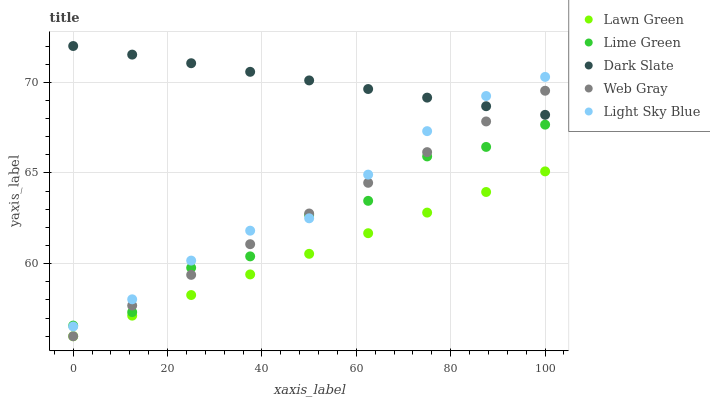Does Lawn Green have the minimum area under the curve?
Answer yes or no. Yes. Does Dark Slate have the maximum area under the curve?
Answer yes or no. Yes. Does Web Gray have the minimum area under the curve?
Answer yes or no. No. Does Web Gray have the maximum area under the curve?
Answer yes or no. No. Is Lawn Green the smoothest?
Answer yes or no. Yes. Is Lime Green the roughest?
Answer yes or no. Yes. Is Web Gray the smoothest?
Answer yes or no. No. Is Web Gray the roughest?
Answer yes or no. No. Does Lawn Green have the lowest value?
Answer yes or no. Yes. Does Lime Green have the lowest value?
Answer yes or no. No. Does Dark Slate have the highest value?
Answer yes or no. Yes. Does Web Gray have the highest value?
Answer yes or no. No. Is Lime Green less than Dark Slate?
Answer yes or no. Yes. Is Light Sky Blue greater than Lawn Green?
Answer yes or no. Yes. Does Light Sky Blue intersect Dark Slate?
Answer yes or no. Yes. Is Light Sky Blue less than Dark Slate?
Answer yes or no. No. Is Light Sky Blue greater than Dark Slate?
Answer yes or no. No. Does Lime Green intersect Dark Slate?
Answer yes or no. No. 